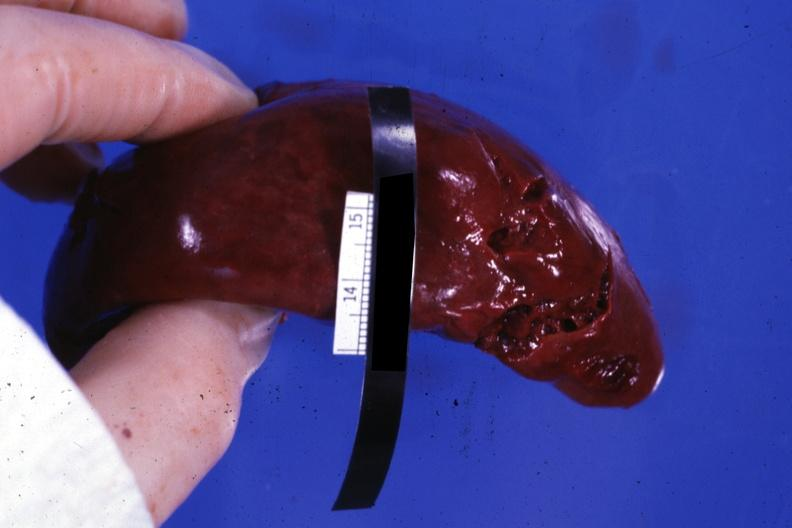s fracture present?
Answer the question using a single word or phrase. No 